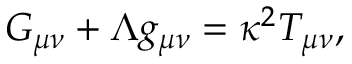Convert formula to latex. <formula><loc_0><loc_0><loc_500><loc_500>G _ { \mu \nu } + \Lambda g _ { \mu \nu } = \kappa ^ { 2 } T _ { \mu \nu } ,</formula> 